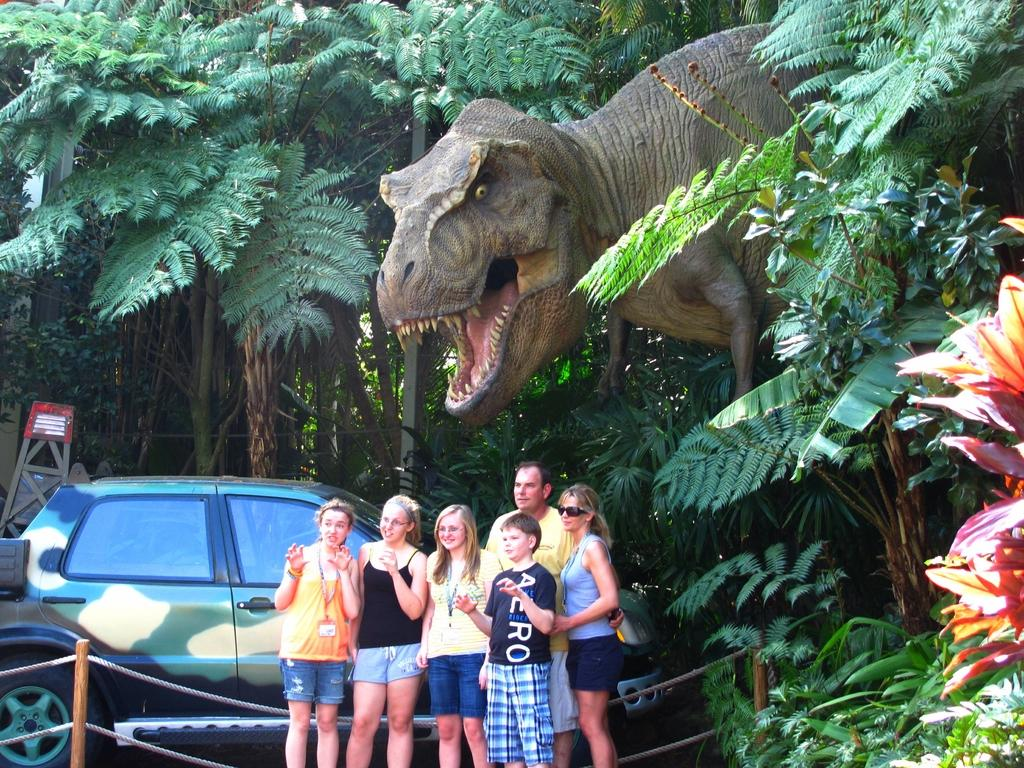What is the main subject of the image? There is a car in the image. What else can be seen in the image besides the car? There is a group of people in the image, and they are standing on the ground. How are the people in the image feeling? The people are smiling in the image. What can be seen in the background of the image? There is a dinosaur and trees in the background of the image. What type of curtain is hanging on the stage in the image? There is no stage or curtain present in the image. How many planes are flying in the sky in the image? There are no planes visible in the image. 